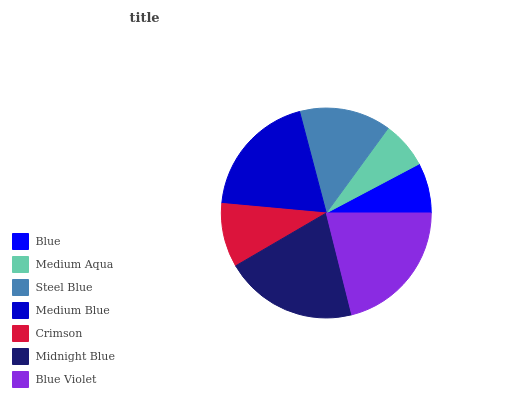Is Medium Aqua the minimum?
Answer yes or no. Yes. Is Blue Violet the maximum?
Answer yes or no. Yes. Is Steel Blue the minimum?
Answer yes or no. No. Is Steel Blue the maximum?
Answer yes or no. No. Is Steel Blue greater than Medium Aqua?
Answer yes or no. Yes. Is Medium Aqua less than Steel Blue?
Answer yes or no. Yes. Is Medium Aqua greater than Steel Blue?
Answer yes or no. No. Is Steel Blue less than Medium Aqua?
Answer yes or no. No. Is Steel Blue the high median?
Answer yes or no. Yes. Is Steel Blue the low median?
Answer yes or no. Yes. Is Medium Aqua the high median?
Answer yes or no. No. Is Medium Blue the low median?
Answer yes or no. No. 